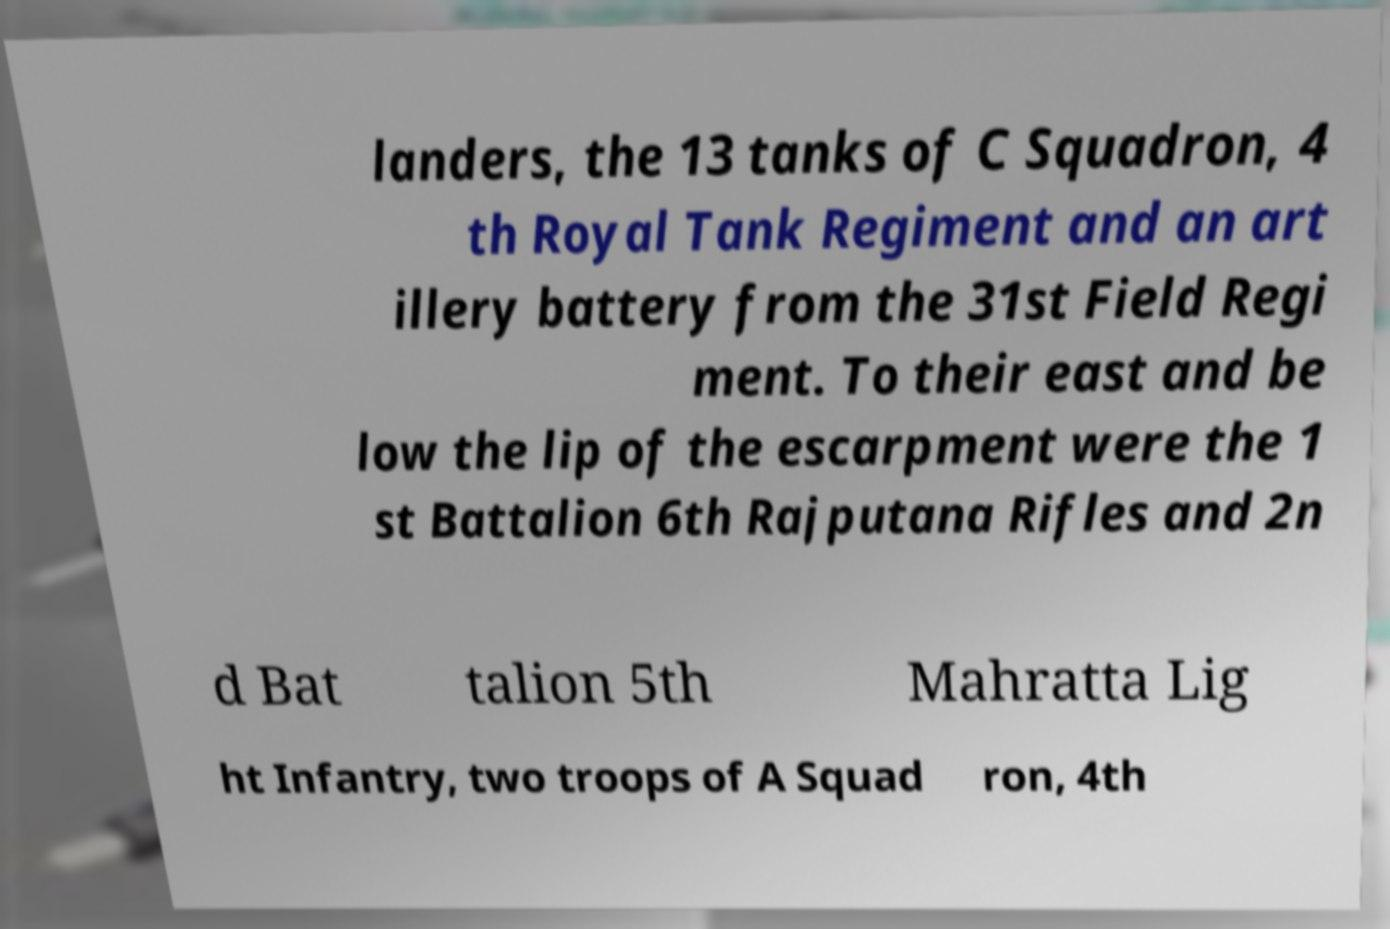Please read and relay the text visible in this image. What does it say? landers, the 13 tanks of C Squadron, 4 th Royal Tank Regiment and an art illery battery from the 31st Field Regi ment. To their east and be low the lip of the escarpment were the 1 st Battalion 6th Rajputana Rifles and 2n d Bat talion 5th Mahratta Lig ht Infantry, two troops of A Squad ron, 4th 